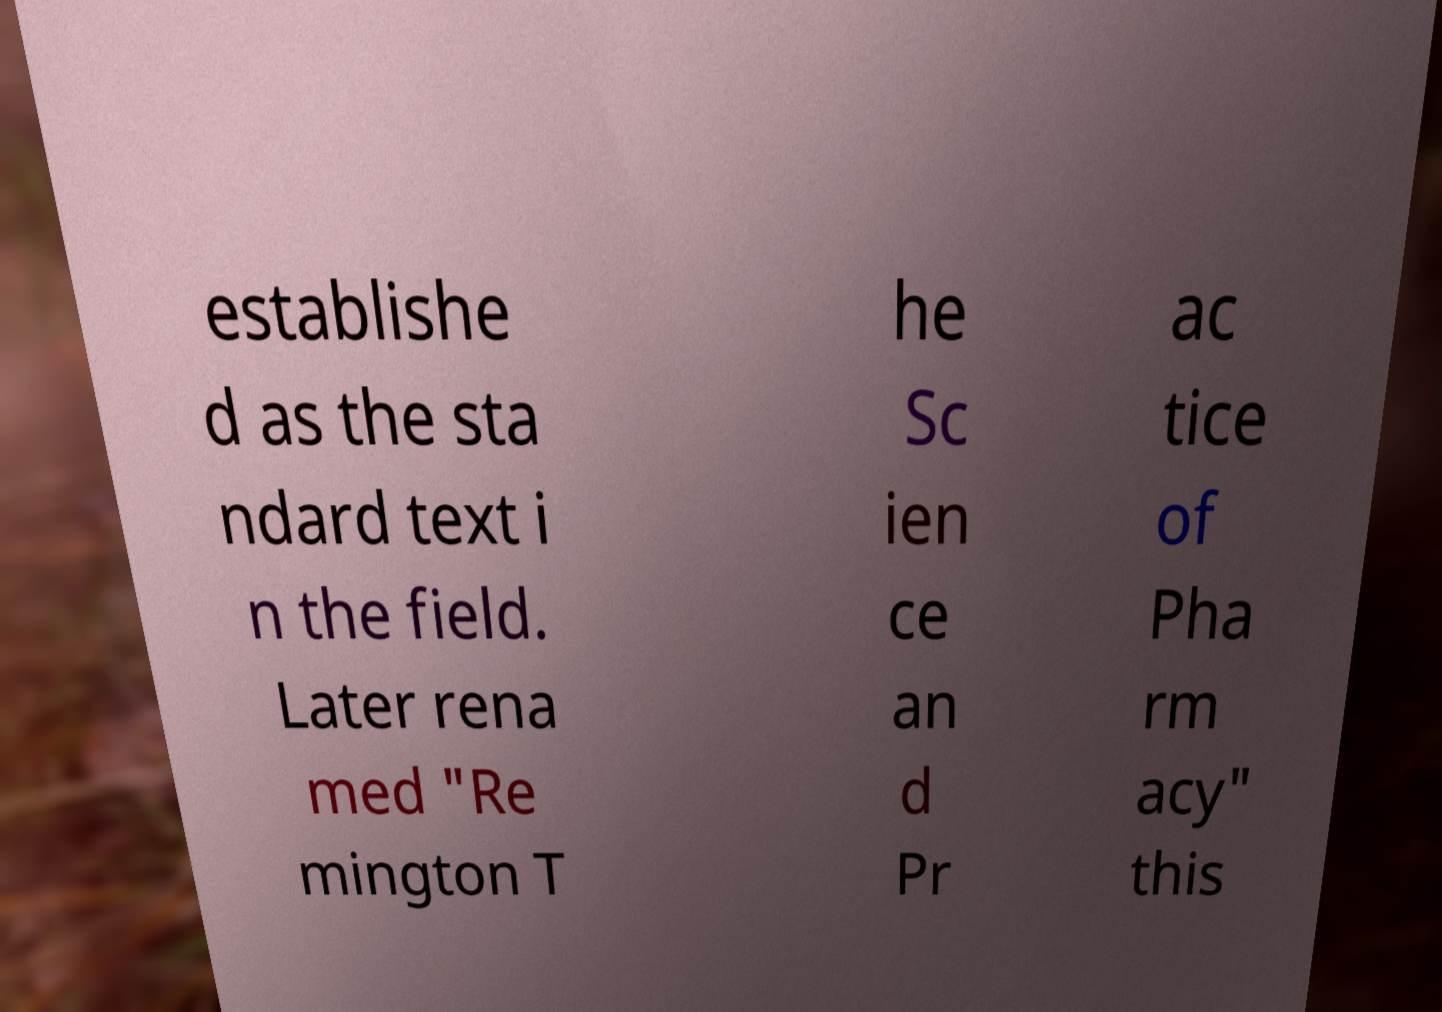What messages or text are displayed in this image? I need them in a readable, typed format. establishe d as the sta ndard text i n the field. Later rena med "Re mington T he Sc ien ce an d Pr ac tice of Pha rm acy" this 